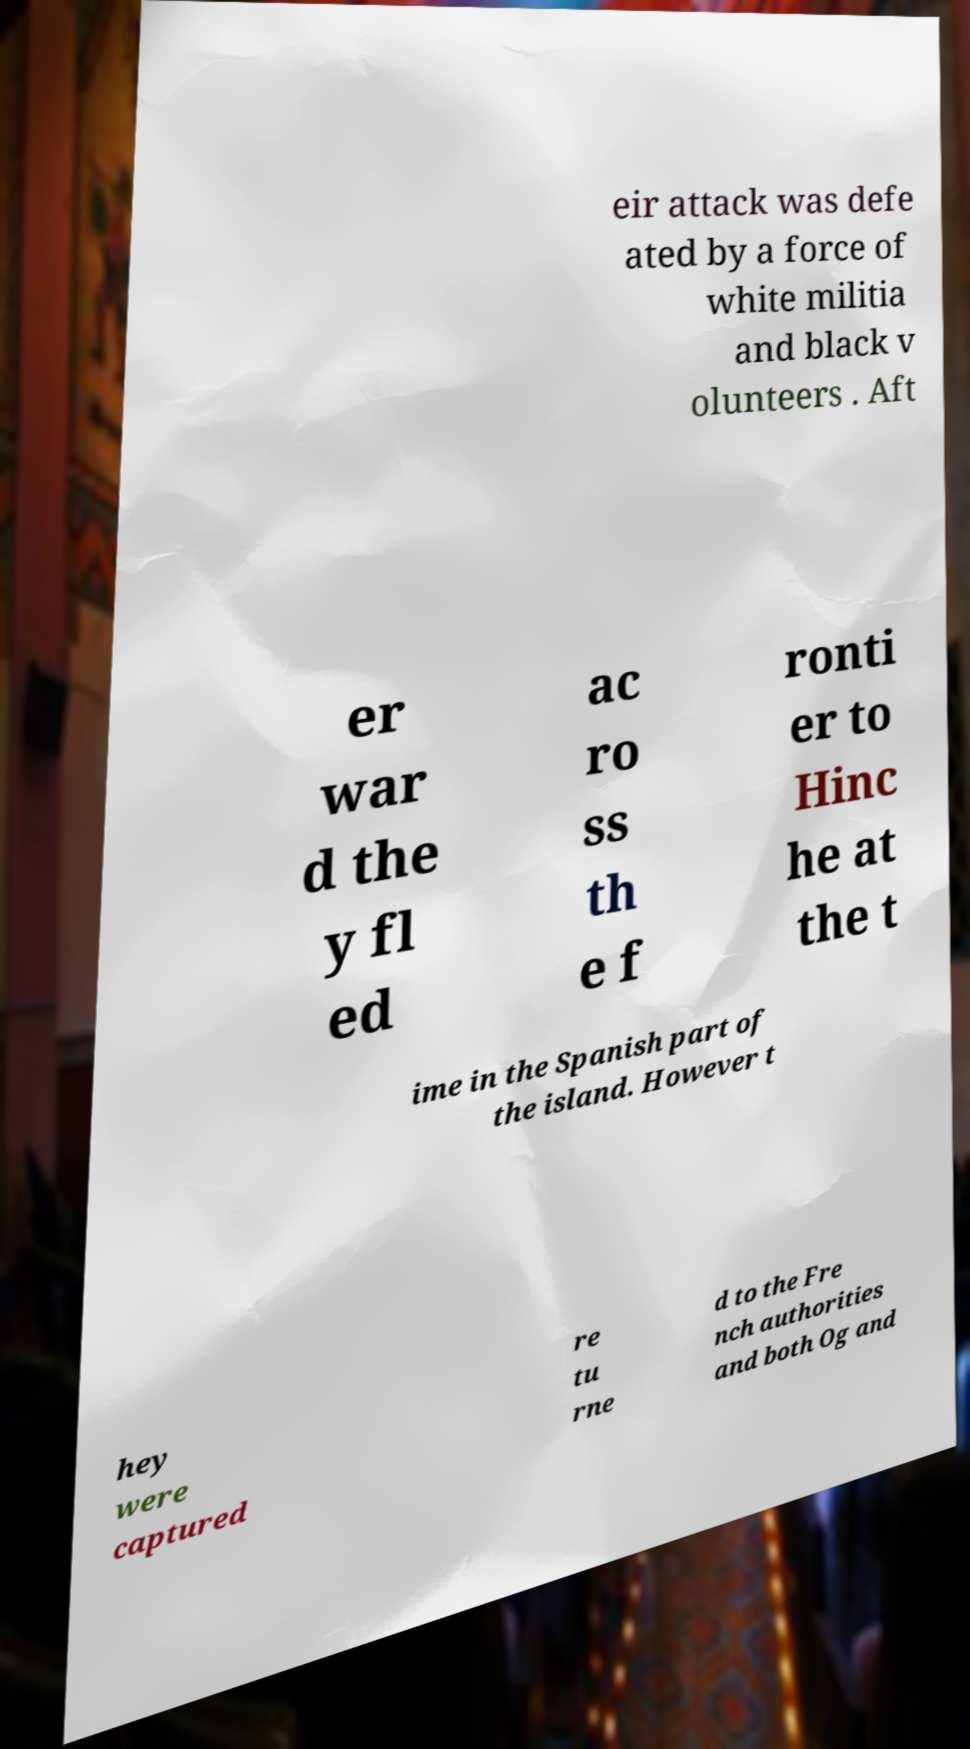For documentation purposes, I need the text within this image transcribed. Could you provide that? eir attack was defe ated by a force of white militia and black v olunteers . Aft er war d the y fl ed ac ro ss th e f ronti er to Hinc he at the t ime in the Spanish part of the island. However t hey were captured re tu rne d to the Fre nch authorities and both Og and 